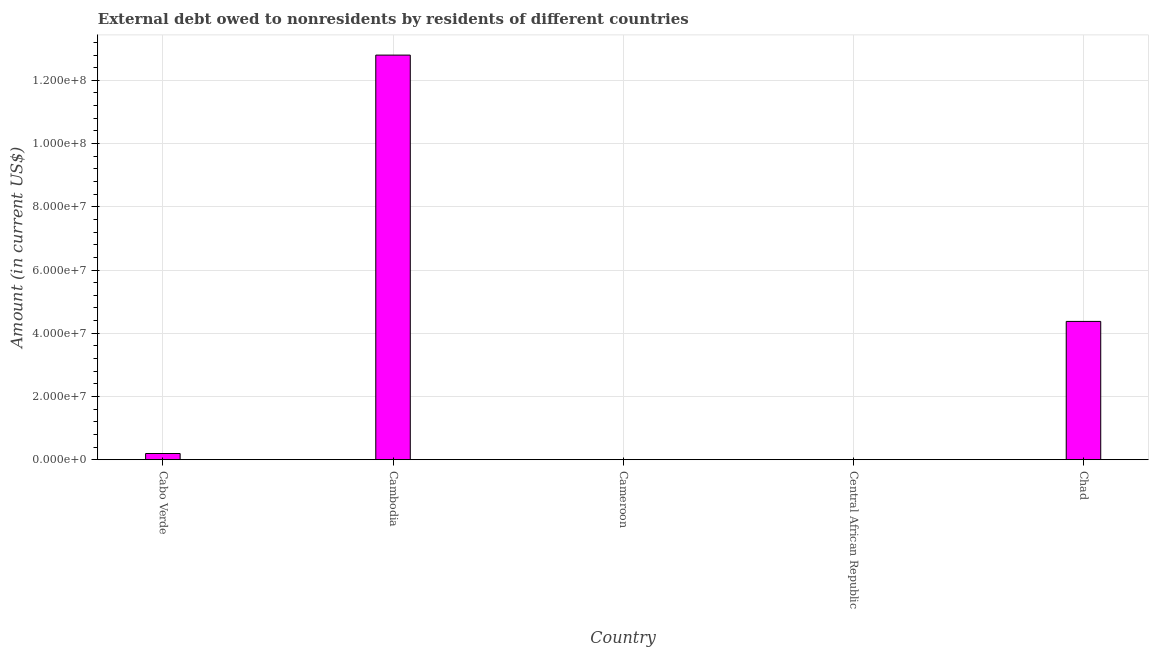What is the title of the graph?
Give a very brief answer. External debt owed to nonresidents by residents of different countries. What is the debt in Cabo Verde?
Keep it short and to the point. 1.96e+06. Across all countries, what is the maximum debt?
Give a very brief answer. 1.28e+08. In which country was the debt maximum?
Your answer should be very brief. Cambodia. What is the sum of the debt?
Offer a terse response. 1.74e+08. What is the difference between the debt in Cabo Verde and Chad?
Give a very brief answer. -4.18e+07. What is the average debt per country?
Make the answer very short. 3.47e+07. What is the median debt?
Your answer should be compact. 1.96e+06. What is the ratio of the debt in Cabo Verde to that in Cambodia?
Make the answer very short. 0.01. What is the difference between the highest and the second highest debt?
Offer a terse response. 8.42e+07. What is the difference between the highest and the lowest debt?
Your answer should be very brief. 1.28e+08. In how many countries, is the debt greater than the average debt taken over all countries?
Provide a short and direct response. 2. Are all the bars in the graph horizontal?
Provide a short and direct response. No. How many countries are there in the graph?
Keep it short and to the point. 5. Are the values on the major ticks of Y-axis written in scientific E-notation?
Provide a succinct answer. Yes. What is the Amount (in current US$) in Cabo Verde?
Make the answer very short. 1.96e+06. What is the Amount (in current US$) in Cambodia?
Make the answer very short. 1.28e+08. What is the Amount (in current US$) of Chad?
Your answer should be very brief. 4.37e+07. What is the difference between the Amount (in current US$) in Cabo Verde and Cambodia?
Your answer should be compact. -1.26e+08. What is the difference between the Amount (in current US$) in Cabo Verde and Chad?
Your answer should be compact. -4.18e+07. What is the difference between the Amount (in current US$) in Cambodia and Chad?
Offer a terse response. 8.42e+07. What is the ratio of the Amount (in current US$) in Cabo Verde to that in Cambodia?
Provide a short and direct response. 0.01. What is the ratio of the Amount (in current US$) in Cabo Verde to that in Chad?
Make the answer very short. 0.04. What is the ratio of the Amount (in current US$) in Cambodia to that in Chad?
Provide a short and direct response. 2.93. 